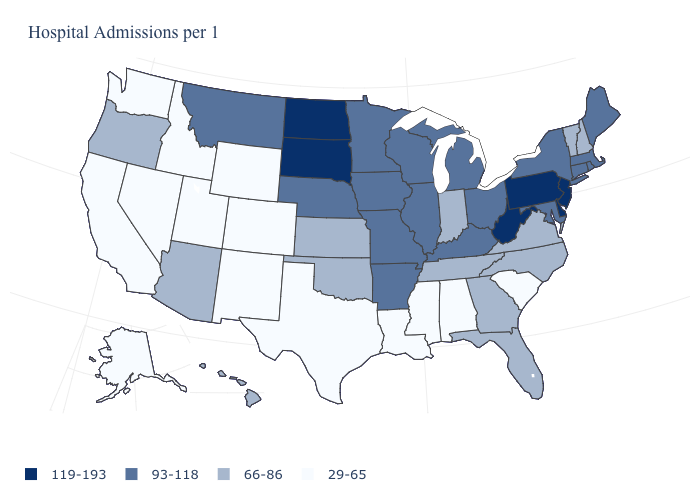Name the states that have a value in the range 29-65?
Be succinct. Alabama, Alaska, California, Colorado, Idaho, Louisiana, Mississippi, Nevada, New Mexico, South Carolina, Texas, Utah, Washington, Wyoming. Name the states that have a value in the range 66-86?
Write a very short answer. Arizona, Florida, Georgia, Hawaii, Indiana, Kansas, New Hampshire, North Carolina, Oklahoma, Oregon, Tennessee, Vermont, Virginia. Does the map have missing data?
Be succinct. No. Which states have the lowest value in the West?
Concise answer only. Alaska, California, Colorado, Idaho, Nevada, New Mexico, Utah, Washington, Wyoming. Name the states that have a value in the range 119-193?
Be succinct. Delaware, New Jersey, North Dakota, Pennsylvania, South Dakota, West Virginia. What is the value of Illinois?
Quick response, please. 93-118. What is the highest value in states that border West Virginia?
Concise answer only. 119-193. Name the states that have a value in the range 66-86?
Keep it brief. Arizona, Florida, Georgia, Hawaii, Indiana, Kansas, New Hampshire, North Carolina, Oklahoma, Oregon, Tennessee, Vermont, Virginia. What is the value of West Virginia?
Short answer required. 119-193. What is the value of Washington?
Be succinct. 29-65. Is the legend a continuous bar?
Keep it brief. No. Does Alaska have the lowest value in the USA?
Answer briefly. Yes. Does Indiana have a higher value than Nevada?
Answer briefly. Yes. What is the highest value in the West ?
Keep it brief. 93-118. Does Kansas have a lower value than Illinois?
Keep it brief. Yes. 